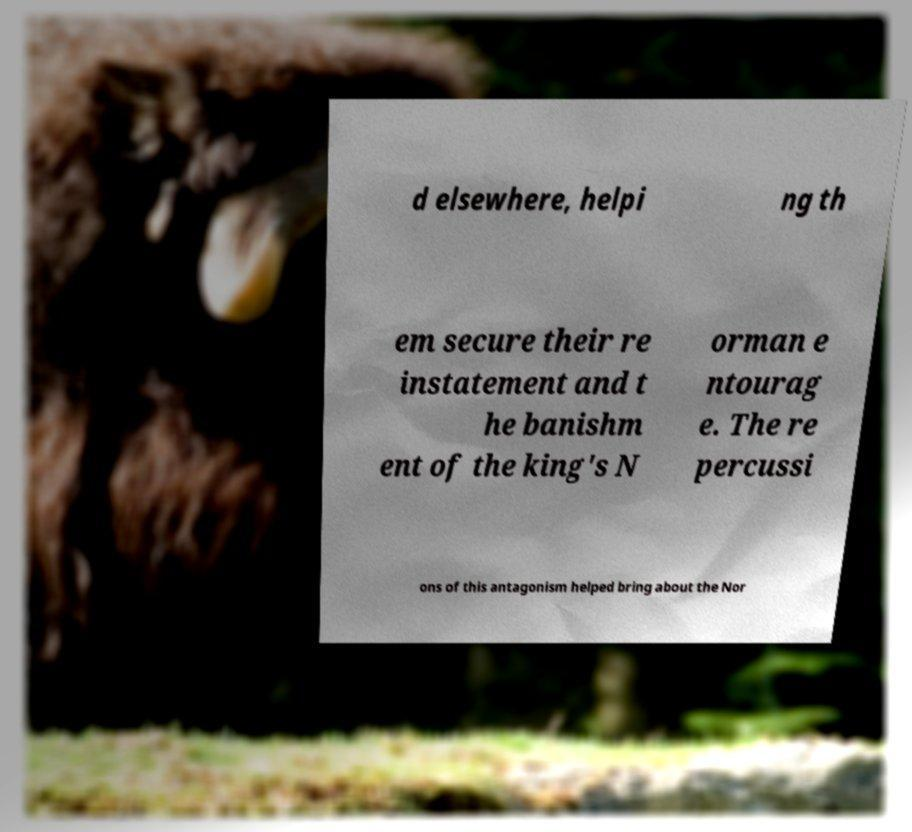Can you read and provide the text displayed in the image?This photo seems to have some interesting text. Can you extract and type it out for me? d elsewhere, helpi ng th em secure their re instatement and t he banishm ent of the king's N orman e ntourag e. The re percussi ons of this antagonism helped bring about the Nor 